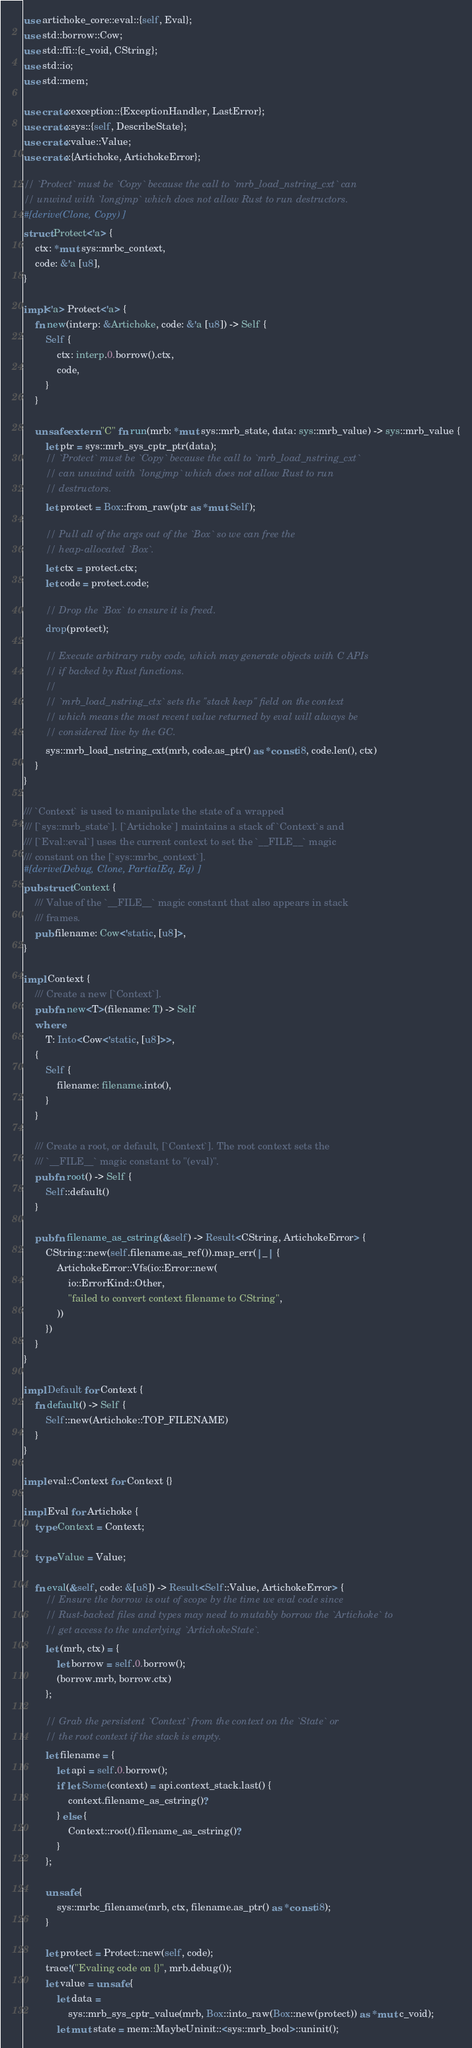<code> <loc_0><loc_0><loc_500><loc_500><_Rust_>use artichoke_core::eval::{self, Eval};
use std::borrow::Cow;
use std::ffi::{c_void, CString};
use std::io;
use std::mem;

use crate::exception::{ExceptionHandler, LastError};
use crate::sys::{self, DescribeState};
use crate::value::Value;
use crate::{Artichoke, ArtichokeError};

// `Protect` must be `Copy` because the call to `mrb_load_nstring_cxt` can
// unwind with `longjmp` which does not allow Rust to run destructors.
#[derive(Clone, Copy)]
struct Protect<'a> {
    ctx: *mut sys::mrbc_context,
    code: &'a [u8],
}

impl<'a> Protect<'a> {
    fn new(interp: &Artichoke, code: &'a [u8]) -> Self {
        Self {
            ctx: interp.0.borrow().ctx,
            code,
        }
    }

    unsafe extern "C" fn run(mrb: *mut sys::mrb_state, data: sys::mrb_value) -> sys::mrb_value {
        let ptr = sys::mrb_sys_cptr_ptr(data);
        // `Protect` must be `Copy` because the call to `mrb_load_nstring_cxt`
        // can unwind with `longjmp` which does not allow Rust to run
        // destructors.
        let protect = Box::from_raw(ptr as *mut Self);

        // Pull all of the args out of the `Box` so we can free the
        // heap-allocated `Box`.
        let ctx = protect.ctx;
        let code = protect.code;

        // Drop the `Box` to ensure it is freed.
        drop(protect);

        // Execute arbitrary ruby code, which may generate objects with C APIs
        // if backed by Rust functions.
        //
        // `mrb_load_nstring_ctx` sets the "stack keep" field on the context
        // which means the most recent value returned by eval will always be
        // considered live by the GC.
        sys::mrb_load_nstring_cxt(mrb, code.as_ptr() as *const i8, code.len(), ctx)
    }
}

/// `Context` is used to manipulate the state of a wrapped
/// [`sys::mrb_state`]. [`Artichoke`] maintains a stack of `Context`s and
/// [`Eval::eval`] uses the current context to set the `__FILE__` magic
/// constant on the [`sys::mrbc_context`].
#[derive(Debug, Clone, PartialEq, Eq)]
pub struct Context {
    /// Value of the `__FILE__` magic constant that also appears in stack
    /// frames.
    pub filename: Cow<'static, [u8]>,
}

impl Context {
    /// Create a new [`Context`].
    pub fn new<T>(filename: T) -> Self
    where
        T: Into<Cow<'static, [u8]>>,
    {
        Self {
            filename: filename.into(),
        }
    }

    /// Create a root, or default, [`Context`]. The root context sets the
    /// `__FILE__` magic constant to "(eval)".
    pub fn root() -> Self {
        Self::default()
    }

    pub fn filename_as_cstring(&self) -> Result<CString, ArtichokeError> {
        CString::new(self.filename.as_ref()).map_err(|_| {
            ArtichokeError::Vfs(io::Error::new(
                io::ErrorKind::Other,
                "failed to convert context filename to CString",
            ))
        })
    }
}

impl Default for Context {
    fn default() -> Self {
        Self::new(Artichoke::TOP_FILENAME)
    }
}

impl eval::Context for Context {}

impl Eval for Artichoke {
    type Context = Context;

    type Value = Value;

    fn eval(&self, code: &[u8]) -> Result<Self::Value, ArtichokeError> {
        // Ensure the borrow is out of scope by the time we eval code since
        // Rust-backed files and types may need to mutably borrow the `Artichoke` to
        // get access to the underlying `ArtichokeState`.
        let (mrb, ctx) = {
            let borrow = self.0.borrow();
            (borrow.mrb, borrow.ctx)
        };

        // Grab the persistent `Context` from the context on the `State` or
        // the root context if the stack is empty.
        let filename = {
            let api = self.0.borrow();
            if let Some(context) = api.context_stack.last() {
                context.filename_as_cstring()?
            } else {
                Context::root().filename_as_cstring()?
            }
        };

        unsafe {
            sys::mrbc_filename(mrb, ctx, filename.as_ptr() as *const i8);
        }

        let protect = Protect::new(self, code);
        trace!("Evaling code on {}", mrb.debug());
        let value = unsafe {
            let data =
                sys::mrb_sys_cptr_value(mrb, Box::into_raw(Box::new(protect)) as *mut c_void);
            let mut state = mem::MaybeUninit::<sys::mrb_bool>::uninit();
</code> 